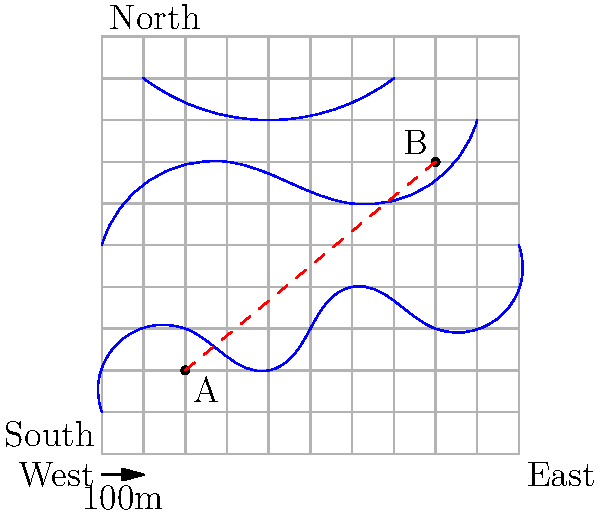As a tactical strategist in an airsoft battle, you need to coordinate your team's movement from point A to point B on the given topographical map. Each grid square represents 100 meters. Estimate:

a) The straight-line distance between points A and B.
b) The approximate angle of elevation from A to B, assuming each contour line represents a 10-meter increase in elevation. Let's approach this step-by-step:

a) To estimate the straight-line distance:
1. Count the grid squares horizontally and vertically between A and B.
   Horizontal distance: 6 squares
   Vertical distance: 5 squares
2. Use the Pythagorean theorem: $c = \sqrt{a^2 + b^2}$
   $c = \sqrt{6^2 + 5^2} = \sqrt{36 + 25} = \sqrt{61} \approx 7.81$
3. Each square is 100m, so multiply by 100:
   $7.81 \times 100 \approx 781$ meters

b) To estimate the angle of elevation:
1. Count the contour lines crossed from A to B: approximately 4 lines
2. Each contour line represents a 10m increase, so total elevation gain is:
   $4 \times 10 = 40$ meters
3. Use the tangent function to calculate the angle:
   $\tan(\theta) = \frac{\text{opposite}}{\text{adjacent}} = \frac{\text{elevation gain}}{\text{horizontal distance}}$
   $\tan(\theta) = \frac{40}{600} = \frac{1}{15} \approx 0.0667$
4. Take the inverse tangent (arctangent):
   $\theta = \arctan(0.0667) \approx 3.81°$
Answer: a) 781 meters
b) 3.81° 